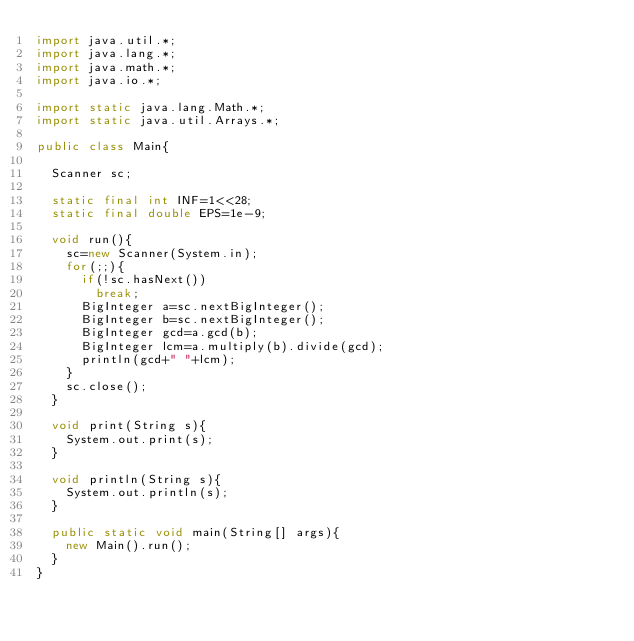Convert code to text. <code><loc_0><loc_0><loc_500><loc_500><_Java_>import java.util.*;
import java.lang.*;
import java.math.*;
import java.io.*;

import static java.lang.Math.*;
import static java.util.Arrays.*;

public class Main{

	Scanner sc;

	static final int INF=1<<28;
	static final double EPS=1e-9;

	void run(){
		sc=new Scanner(System.in);
		for(;;){
			if(!sc.hasNext())
				break;
			BigInteger a=sc.nextBigInteger();
			BigInteger b=sc.nextBigInteger();
			BigInteger gcd=a.gcd(b);
			BigInteger lcm=a.multiply(b).divide(gcd);
			println(gcd+" "+lcm);
		}
		sc.close();
	}

	void print(String s){
		System.out.print(s);
	}

	void println(String s){
		System.out.println(s);
	}

	public static void main(String[] args){
		new Main().run();
	}
}</code> 